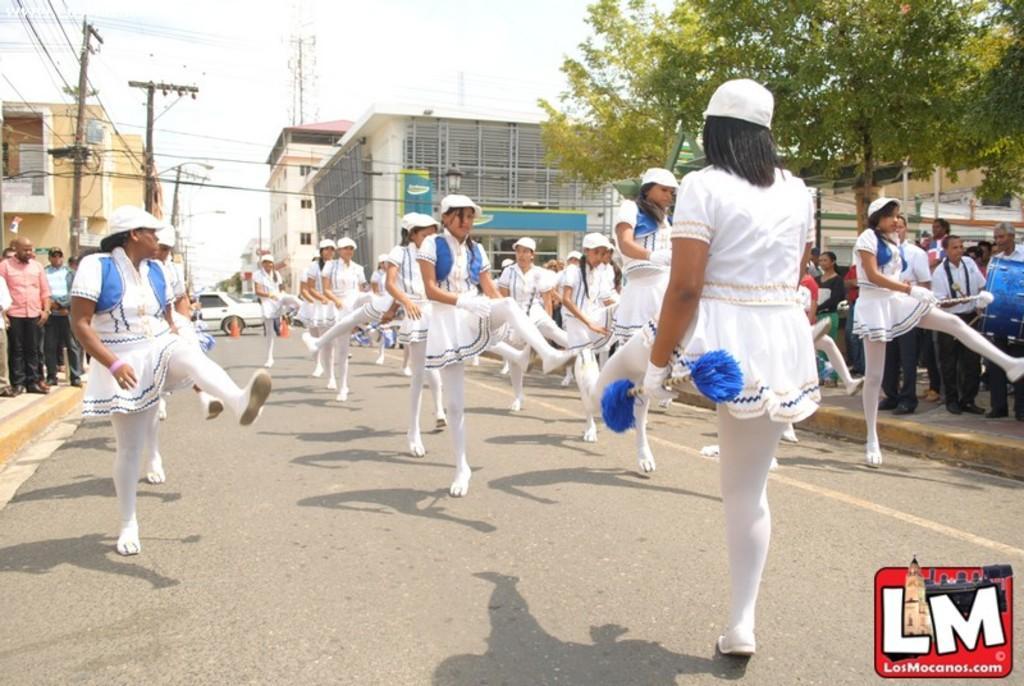Please provide a concise description of this image. In this picture we can describe about group of girls wearing white color dress and leggings doing exercise on the road. Behind we can see some small building and electric pole with cable. 